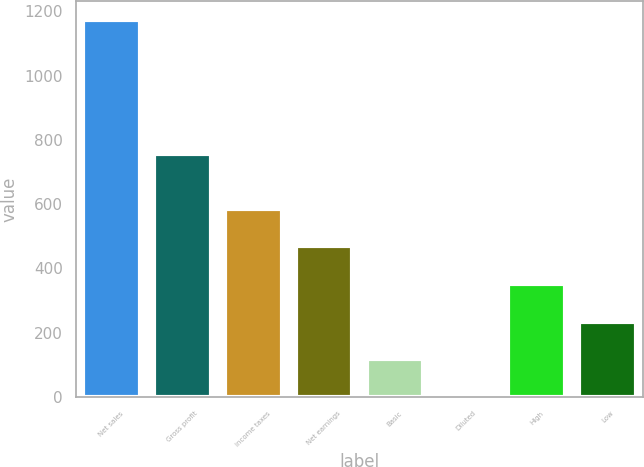<chart> <loc_0><loc_0><loc_500><loc_500><bar_chart><fcel>Net sales<fcel>Gross profit<fcel>income taxes<fcel>Net earnings<fcel>Basic<fcel>Diluted<fcel>High<fcel>Low<nl><fcel>1171.9<fcel>754.6<fcel>586.09<fcel>468.93<fcel>117.45<fcel>0.29<fcel>351.77<fcel>234.61<nl></chart> 